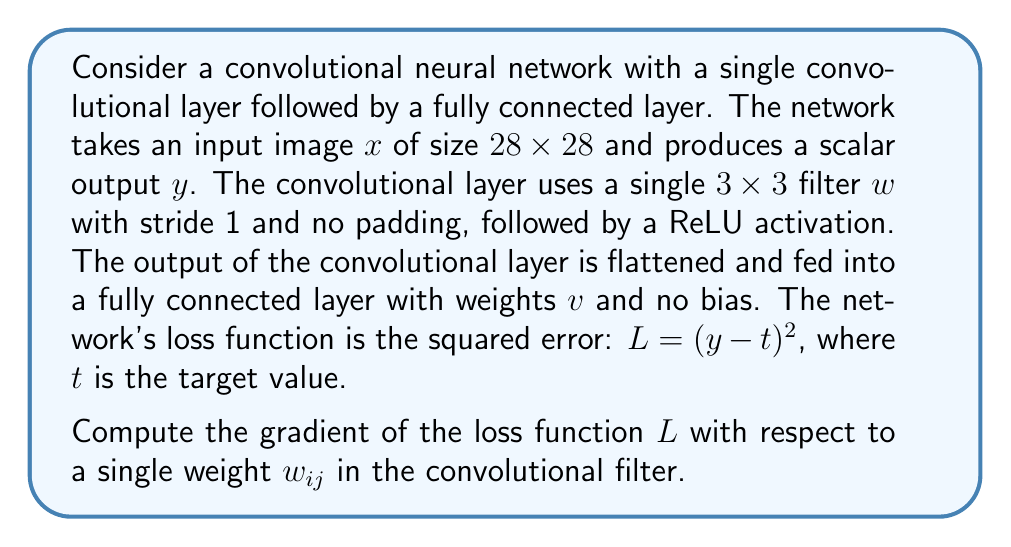Can you solve this math problem? To compute the gradient of the loss function with respect to a single weight in the convolutional filter, we'll use the chain rule of differentiation. Let's break this down step by step:

1) First, let's define the forward pass of the network:
   - Convolutional layer output: $z = \text{conv}(x, w)$
   - ReLU activation: $a = \max(0, z)$
   - Flattened output: $f = \text{flatten}(a)$
   - Fully connected layer output: $y = v^T f$

2) The loss function is $L = (y - t)^2$

3) Using the chain rule, we can express the gradient as:

   $$\frac{\partial L}{\partial w_{ij}} = \frac{\partial L}{\partial y} \cdot \frac{\partial y}{\partial f} \cdot \frac{\partial f}{\partial a} \cdot \frac{\partial a}{\partial z} \cdot \frac{\partial z}{\partial w_{ij}}$$

4) Let's compute each term:
   
   a) $\frac{\partial L}{\partial y} = 2(y - t)$
   
   b) $\frac{\partial y}{\partial f} = v$ (transpose of $v^T$)
   
   c) $\frac{\partial f}{\partial a}$ is a reshape operation, which doesn't change values
   
   d) $\frac{\partial a}{\partial z} = \mathbb{1}(z > 0)$ (indicator function, 1 if $z > 0$, 0 otherwise)
   
   e) $\frac{\partial z}{\partial w_{ij}}$ is the input patch that corresponds to $w_{ij}$ in the convolution operation

5) Putting it all together:

   $$\frac{\partial L}{\partial w_{ij}} = 2(y - t) \cdot v \cdot \mathbb{1}(z > 0) \cdot x_{patch}$$

   where $x_{patch}$ is the input patch that corresponds to $w_{ij}$ in the convolution operation.

6) This gradient needs to be computed for each position where the filter is applied and then summed up to get the total gradient for $w_{ij}$.
Answer: $\frac{\partial L}{\partial w_{ij}} = \sum_{positions} 2(y - t) \cdot v \cdot \mathbb{1}(z > 0) \cdot x_{patch}$ 